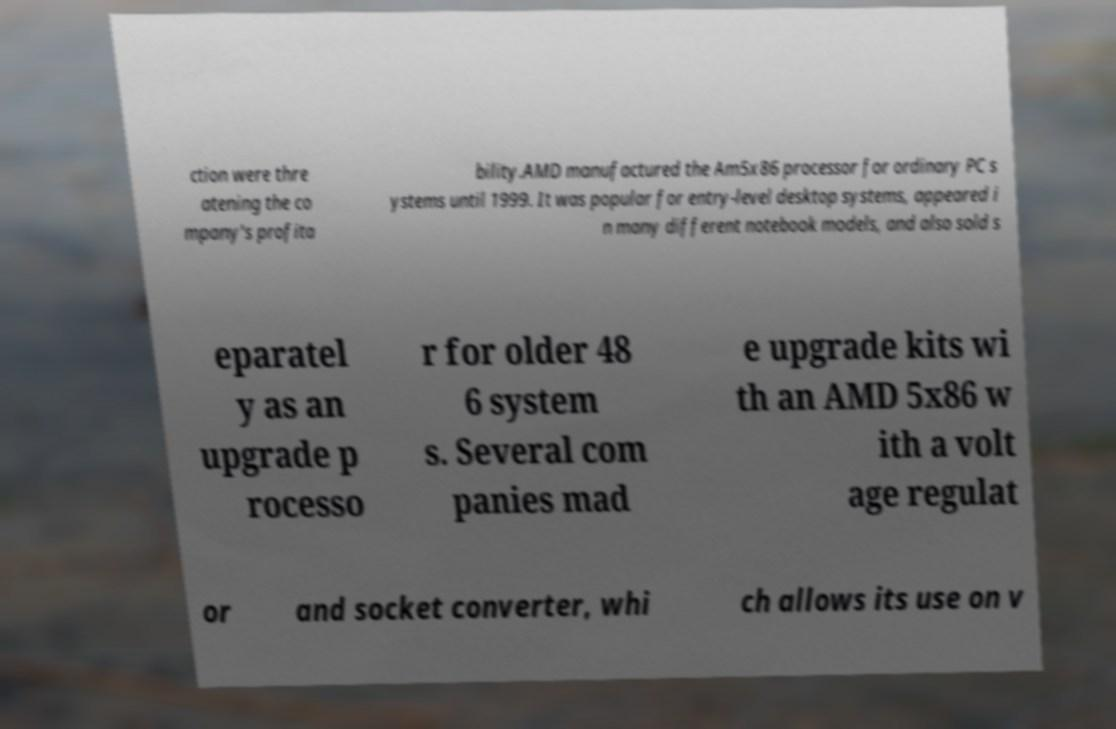There's text embedded in this image that I need extracted. Can you transcribe it verbatim? ction were thre atening the co mpany's profita bility.AMD manufactured the Am5x86 processor for ordinary PC s ystems until 1999. It was popular for entry-level desktop systems, appeared i n many different notebook models, and also sold s eparatel y as an upgrade p rocesso r for older 48 6 system s. Several com panies mad e upgrade kits wi th an AMD 5x86 w ith a volt age regulat or and socket converter, whi ch allows its use on v 